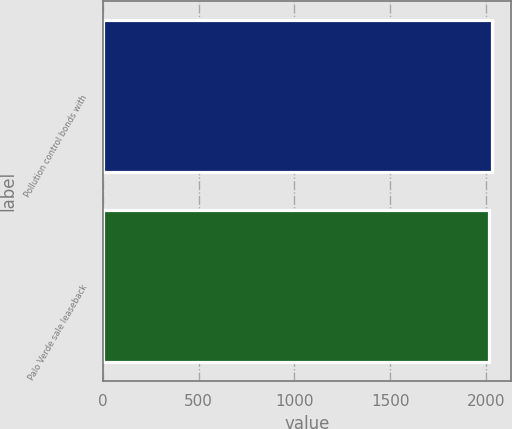Convert chart to OTSL. <chart><loc_0><loc_0><loc_500><loc_500><bar_chart><fcel>Pollution control bonds with<fcel>Palo Verde sale leaseback<nl><fcel>2029<fcel>2015<nl></chart> 